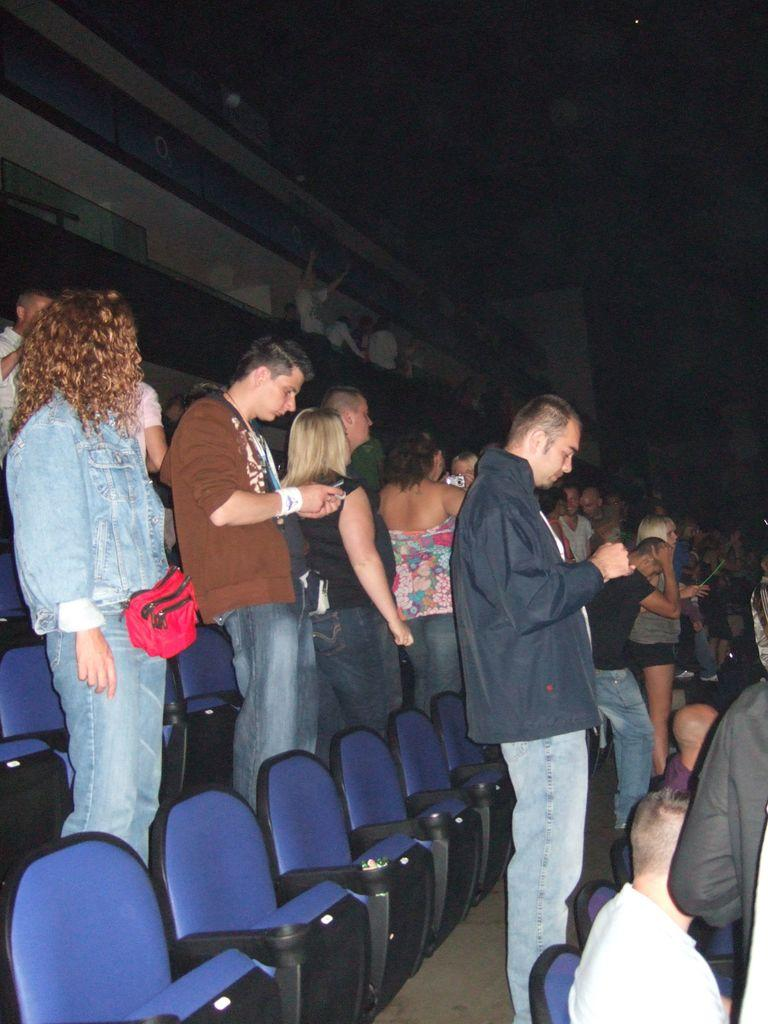What are the people in the image doing? There are people standing and operating mobiles in the image. Are there any people sitting in the image? Yes, there are people sitting on chairs in the image. What type of haircut is being offered in the image? There is no indication of a haircut or any hair-related service in the image. 